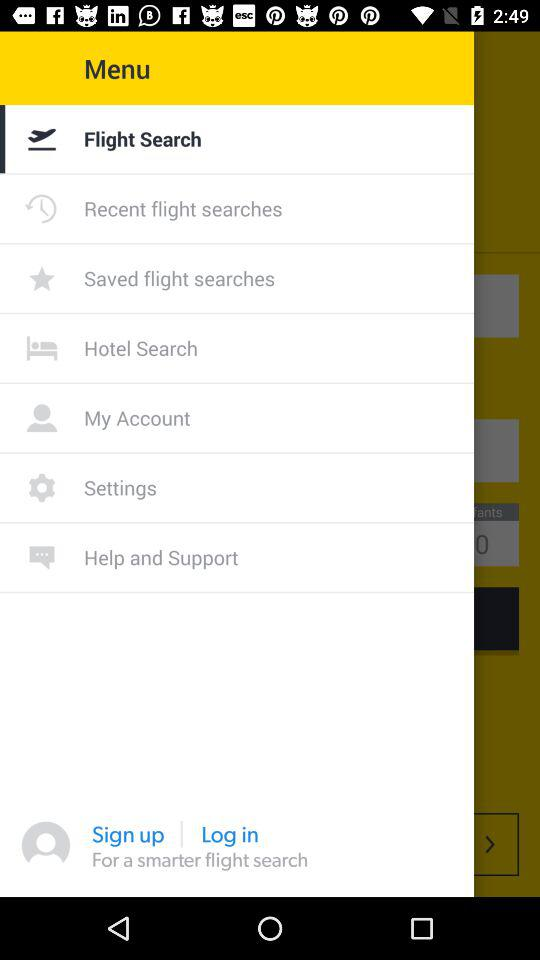What option is selected in the menu? The selected option is "Flight Search". 